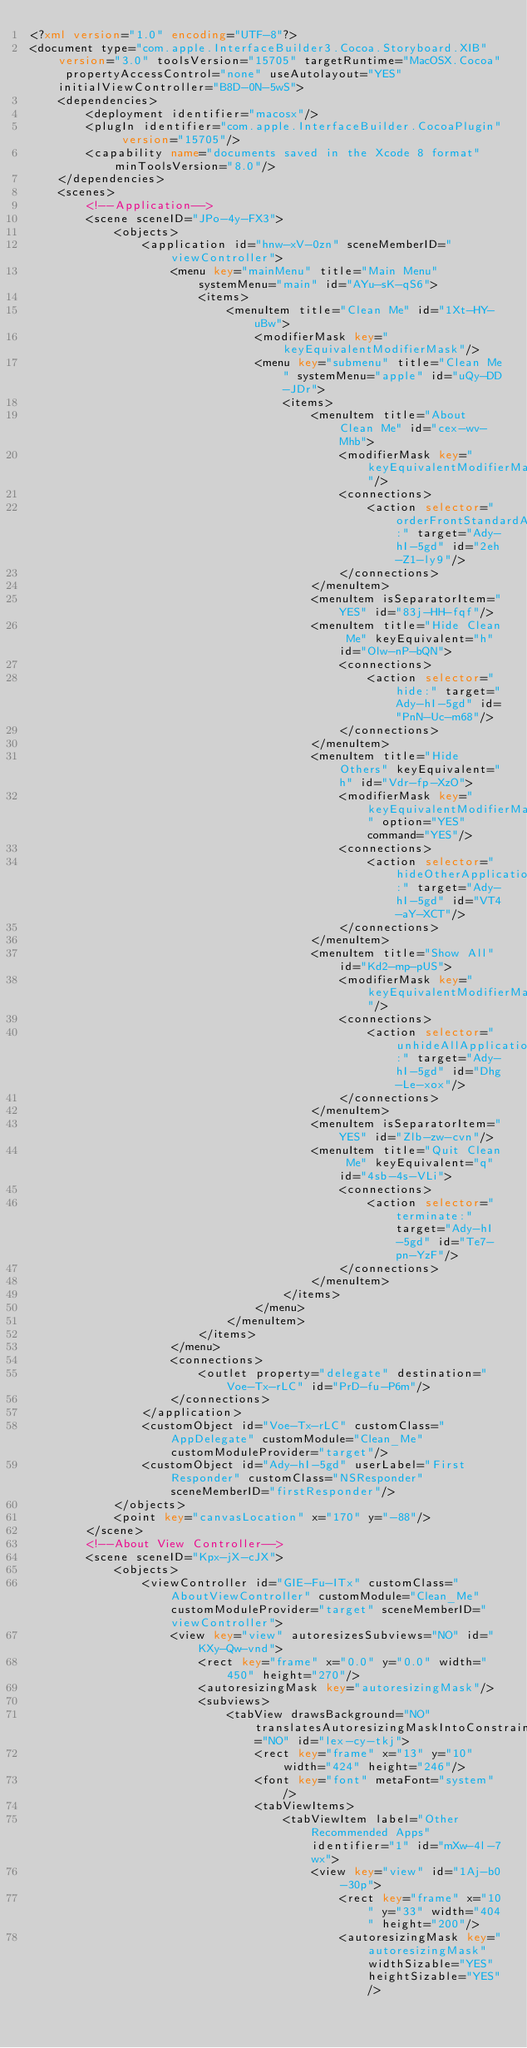Convert code to text. <code><loc_0><loc_0><loc_500><loc_500><_XML_><?xml version="1.0" encoding="UTF-8"?>
<document type="com.apple.InterfaceBuilder3.Cocoa.Storyboard.XIB" version="3.0" toolsVersion="15705" targetRuntime="MacOSX.Cocoa" propertyAccessControl="none" useAutolayout="YES" initialViewController="B8D-0N-5wS">
    <dependencies>
        <deployment identifier="macosx"/>
        <plugIn identifier="com.apple.InterfaceBuilder.CocoaPlugin" version="15705"/>
        <capability name="documents saved in the Xcode 8 format" minToolsVersion="8.0"/>
    </dependencies>
    <scenes>
        <!--Application-->
        <scene sceneID="JPo-4y-FX3">
            <objects>
                <application id="hnw-xV-0zn" sceneMemberID="viewController">
                    <menu key="mainMenu" title="Main Menu" systemMenu="main" id="AYu-sK-qS6">
                        <items>
                            <menuItem title="Clean Me" id="1Xt-HY-uBw">
                                <modifierMask key="keyEquivalentModifierMask"/>
                                <menu key="submenu" title="Clean Me" systemMenu="apple" id="uQy-DD-JDr">
                                    <items>
                                        <menuItem title="About Clean Me" id="cex-wv-Mhb">
                                            <modifierMask key="keyEquivalentModifierMask"/>
                                            <connections>
                                                <action selector="orderFrontStandardAboutPanel:" target="Ady-hI-5gd" id="2eh-Z1-ly9"/>
                                            </connections>
                                        </menuItem>
                                        <menuItem isSeparatorItem="YES" id="83j-HH-fqf"/>
                                        <menuItem title="Hide Clean Me" keyEquivalent="h" id="Olw-nP-bQN">
                                            <connections>
                                                <action selector="hide:" target="Ady-hI-5gd" id="PnN-Uc-m68"/>
                                            </connections>
                                        </menuItem>
                                        <menuItem title="Hide Others" keyEquivalent="h" id="Vdr-fp-XzO">
                                            <modifierMask key="keyEquivalentModifierMask" option="YES" command="YES"/>
                                            <connections>
                                                <action selector="hideOtherApplications:" target="Ady-hI-5gd" id="VT4-aY-XCT"/>
                                            </connections>
                                        </menuItem>
                                        <menuItem title="Show All" id="Kd2-mp-pUS">
                                            <modifierMask key="keyEquivalentModifierMask"/>
                                            <connections>
                                                <action selector="unhideAllApplications:" target="Ady-hI-5gd" id="Dhg-Le-xox"/>
                                            </connections>
                                        </menuItem>
                                        <menuItem isSeparatorItem="YES" id="Zlb-zw-cvn"/>
                                        <menuItem title="Quit Clean Me" keyEquivalent="q" id="4sb-4s-VLi">
                                            <connections>
                                                <action selector="terminate:" target="Ady-hI-5gd" id="Te7-pn-YzF"/>
                                            </connections>
                                        </menuItem>
                                    </items>
                                </menu>
                            </menuItem>
                        </items>
                    </menu>
                    <connections>
                        <outlet property="delegate" destination="Voe-Tx-rLC" id="PrD-fu-P6m"/>
                    </connections>
                </application>
                <customObject id="Voe-Tx-rLC" customClass="AppDelegate" customModule="Clean_Me" customModuleProvider="target"/>
                <customObject id="Ady-hI-5gd" userLabel="First Responder" customClass="NSResponder" sceneMemberID="firstResponder"/>
            </objects>
            <point key="canvasLocation" x="170" y="-88"/>
        </scene>
        <!--About View Controller-->
        <scene sceneID="Kpx-jX-cJX">
            <objects>
                <viewController id="GIE-Fu-ITx" customClass="AboutViewController" customModule="Clean_Me" customModuleProvider="target" sceneMemberID="viewController">
                    <view key="view" autoresizesSubviews="NO" id="KXy-Qw-vnd">
                        <rect key="frame" x="0.0" y="0.0" width="450" height="270"/>
                        <autoresizingMask key="autoresizingMask"/>
                        <subviews>
                            <tabView drawsBackground="NO" translatesAutoresizingMaskIntoConstraints="NO" id="lex-cy-tkj">
                                <rect key="frame" x="13" y="10" width="424" height="246"/>
                                <font key="font" metaFont="system"/>
                                <tabViewItems>
                                    <tabViewItem label="Other Recommended Apps" identifier="1" id="mXw-4l-7wx">
                                        <view key="view" id="1Aj-b0-30p">
                                            <rect key="frame" x="10" y="33" width="404" height="200"/>
                                            <autoresizingMask key="autoresizingMask" widthSizable="YES" heightSizable="YES"/></code> 